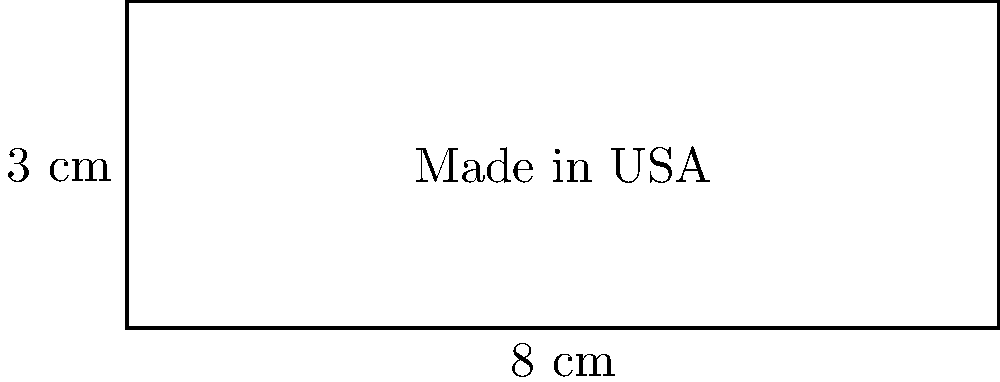A patriotic American manufacturing company wants to create rectangular "Made in USA" product labels for their goods. The label measures 8 cm in width and 3 cm in height. What is the perimeter of this label? To calculate the perimeter of a rectangular label, we need to sum up the lengths of all four sides. Let's approach this step-by-step:

1. Identify the dimensions:
   - Width (w) = 8 cm
   - Height (h) = 3 cm

2. Recall the formula for the perimeter of a rectangle:
   $$ P = 2w + 2h $$
   Where P is the perimeter, w is the width, and h is the height.

3. Substitute the values into the formula:
   $$ P = 2(8 \text{ cm}) + 2(3 \text{ cm}) $$

4. Simplify:
   $$ P = 16 \text{ cm} + 6 \text{ cm} = 22 \text{ cm} $$

Therefore, the perimeter of the "Made in USA" label is 22 cm.
Answer: 22 cm 